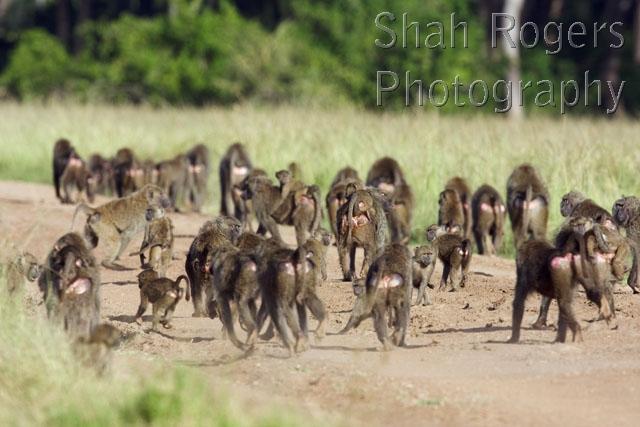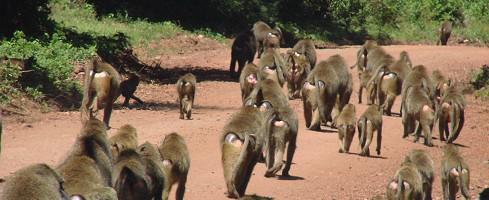The first image is the image on the left, the second image is the image on the right. Examine the images to the left and right. Is the description "In one of the images all of the monkeys are walking down the road away from the camera." accurate? Answer yes or no. Yes. The first image is the image on the left, the second image is the image on the right. Evaluate the accuracy of this statement regarding the images: "There is a large group of baboons walking on a dirt road.". Is it true? Answer yes or no. Yes. 